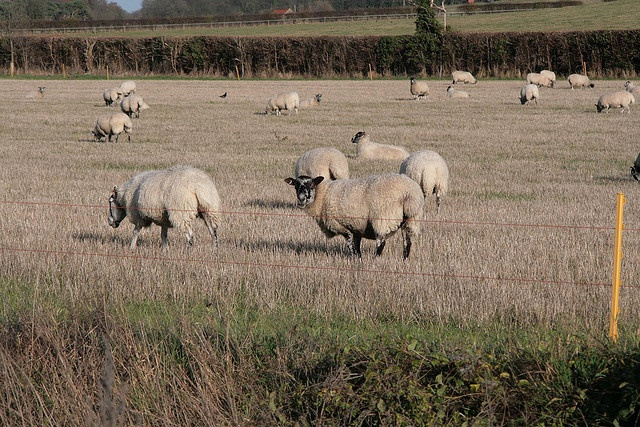Describe the objects in this image and their specific colors. I can see sheep in gray, darkgray, tan, and black tones, sheep in gray, darkgray, and tan tones, sheep in gray, tan, and darkgray tones, sheep in gray, darkgray, and tan tones, and sheep in gray and tan tones in this image. 